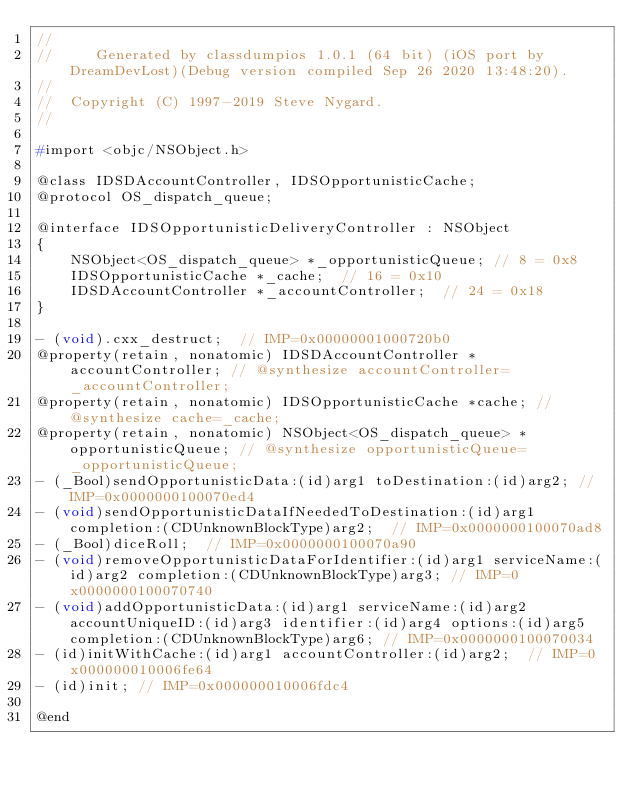Convert code to text. <code><loc_0><loc_0><loc_500><loc_500><_C_>//
//     Generated by classdumpios 1.0.1 (64 bit) (iOS port by DreamDevLost)(Debug version compiled Sep 26 2020 13:48:20).
//
//  Copyright (C) 1997-2019 Steve Nygard.
//

#import <objc/NSObject.h>

@class IDSDAccountController, IDSOpportunisticCache;
@protocol OS_dispatch_queue;

@interface IDSOpportunisticDeliveryController : NSObject
{
    NSObject<OS_dispatch_queue> *_opportunisticQueue;	// 8 = 0x8
    IDSOpportunisticCache *_cache;	// 16 = 0x10
    IDSDAccountController *_accountController;	// 24 = 0x18
}

- (void).cxx_destruct;	// IMP=0x00000001000720b0
@property(retain, nonatomic) IDSDAccountController *accountController; // @synthesize accountController=_accountController;
@property(retain, nonatomic) IDSOpportunisticCache *cache; // @synthesize cache=_cache;
@property(retain, nonatomic) NSObject<OS_dispatch_queue> *opportunisticQueue; // @synthesize opportunisticQueue=_opportunisticQueue;
- (_Bool)sendOpportunisticData:(id)arg1 toDestination:(id)arg2;	// IMP=0x0000000100070ed4
- (void)sendOpportunisticDataIfNeededToDestination:(id)arg1 completion:(CDUnknownBlockType)arg2;	// IMP=0x0000000100070ad8
- (_Bool)diceRoll;	// IMP=0x0000000100070a90
- (void)removeOpportunisticDataForIdentifier:(id)arg1 serviceName:(id)arg2 completion:(CDUnknownBlockType)arg3;	// IMP=0x0000000100070740
- (void)addOpportunisticData:(id)arg1 serviceName:(id)arg2 accountUniqueID:(id)arg3 identifier:(id)arg4 options:(id)arg5 completion:(CDUnknownBlockType)arg6;	// IMP=0x0000000100070034
- (id)initWithCache:(id)arg1 accountController:(id)arg2;	// IMP=0x000000010006fe64
- (id)init;	// IMP=0x000000010006fdc4

@end

</code> 